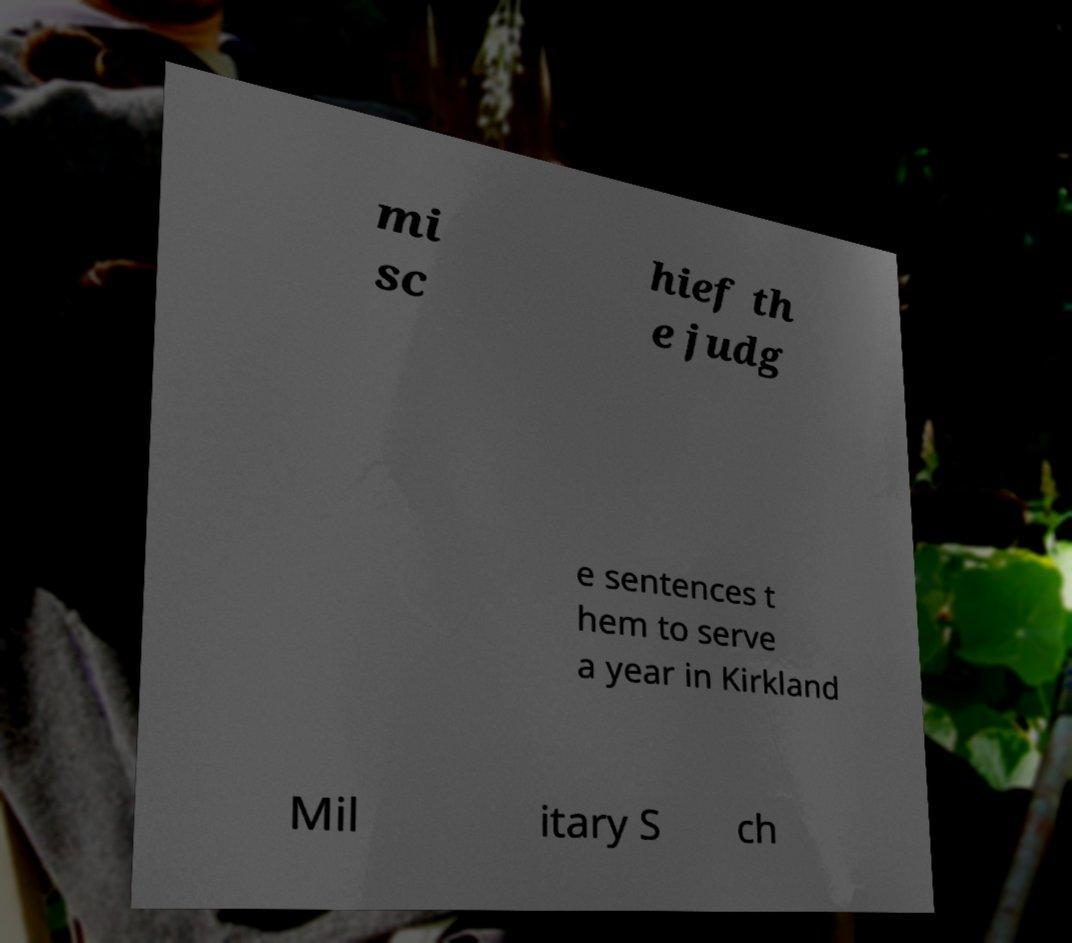Please identify and transcribe the text found in this image. mi sc hief th e judg e sentences t hem to serve a year in Kirkland Mil itary S ch 